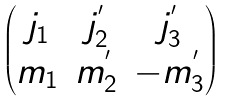<formula> <loc_0><loc_0><loc_500><loc_500>\begin{pmatrix} j _ { 1 } & j _ { 2 } ^ { ^ { \prime } } & j _ { 3 } ^ { ^ { \prime } } \\ m _ { 1 } & m _ { 2 } ^ { ^ { \prime } } & - m _ { 3 } ^ { ^ { \prime } } \end{pmatrix}</formula> 